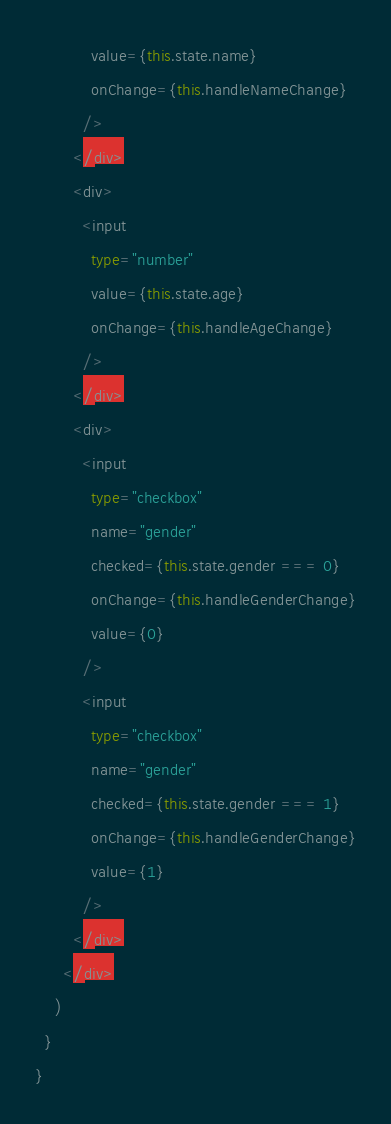<code> <loc_0><loc_0><loc_500><loc_500><_TypeScript_>            value={this.state.name}
            onChange={this.handleNameChange}
          />
        </div>
        <div>
          <input
            type="number"
            value={this.state.age}
            onChange={this.handleAgeChange}
          />
        </div>
        <div>
          <input
            type="checkbox"
            name="gender"
            checked={this.state.gender === 0}
            onChange={this.handleGenderChange}
            value={0}
          />
          <input
            type="checkbox"
            name="gender"
            checked={this.state.gender === 1}
            onChange={this.handleGenderChange}
            value={1}
          />
        </div>
      </div>
    )
  }
}
</code> 